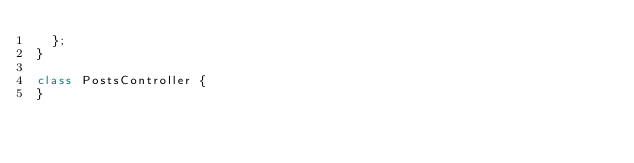Convert code to text. <code><loc_0><loc_0><loc_500><loc_500><_JavaScript_>  };
}

class PostsController {
}
</code> 